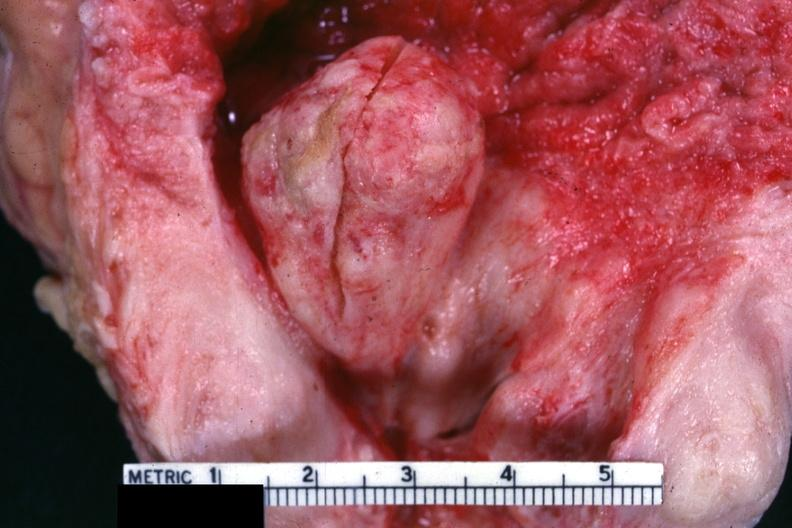what does this image show?
Answer the question using a single word or phrase. Close-up view of large median lobe extending into floor of bladder 